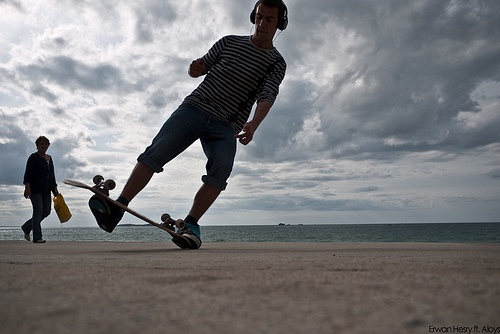Describe the objects in this image and their specific colors. I can see people in darkgray, black, gray, and lightgray tones, people in darkgray, black, gray, and lightgray tones, and skateboard in darkgray, black, gray, and lightgray tones in this image. 